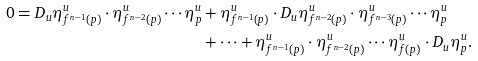<formula> <loc_0><loc_0><loc_500><loc_500>0 = D _ { u } \eta _ { f ^ { n - 1 } ( p ) } ^ { u } \cdot \eta _ { f ^ { n - 2 } ( p ) } ^ { u } \cdots \eta _ { p } ^ { u } & + \eta _ { f ^ { n - 1 } ( p ) } ^ { u } \cdot D _ { u } \eta _ { f ^ { n - 2 } ( p ) } ^ { u } \cdot \eta _ { f ^ { n - 3 } ( p ) } ^ { u } \cdots \eta _ { p } ^ { u } \\ & + \cdots + \eta _ { f ^ { n - 1 } ( p ) } ^ { u } \cdot \eta _ { f ^ { n - 2 } ( p ) } ^ { u } \cdots \eta _ { f ( p ) } ^ { u } \cdot D _ { u } \eta _ { p } ^ { u } .</formula> 